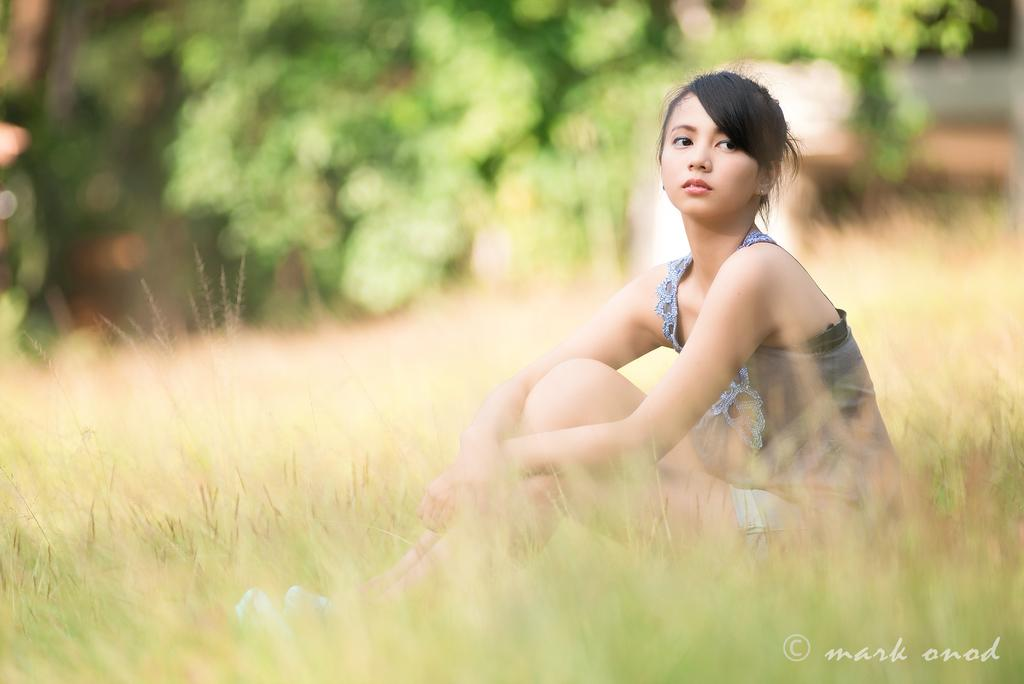What is the lady in the image doing? The lady is sitting on the grass in the image. Can you describe the background of the image? The background of the image is blurred. Is there any text visible in the image? Yes, there is some text in the bottom right corner of the image. What type of soap is the lady holding in the image? There is no soap present in the image; the lady is sitting on the grass. How many crows can be seen flying in the background of the image? There are no crows visible in the image, as the background is blurred. 